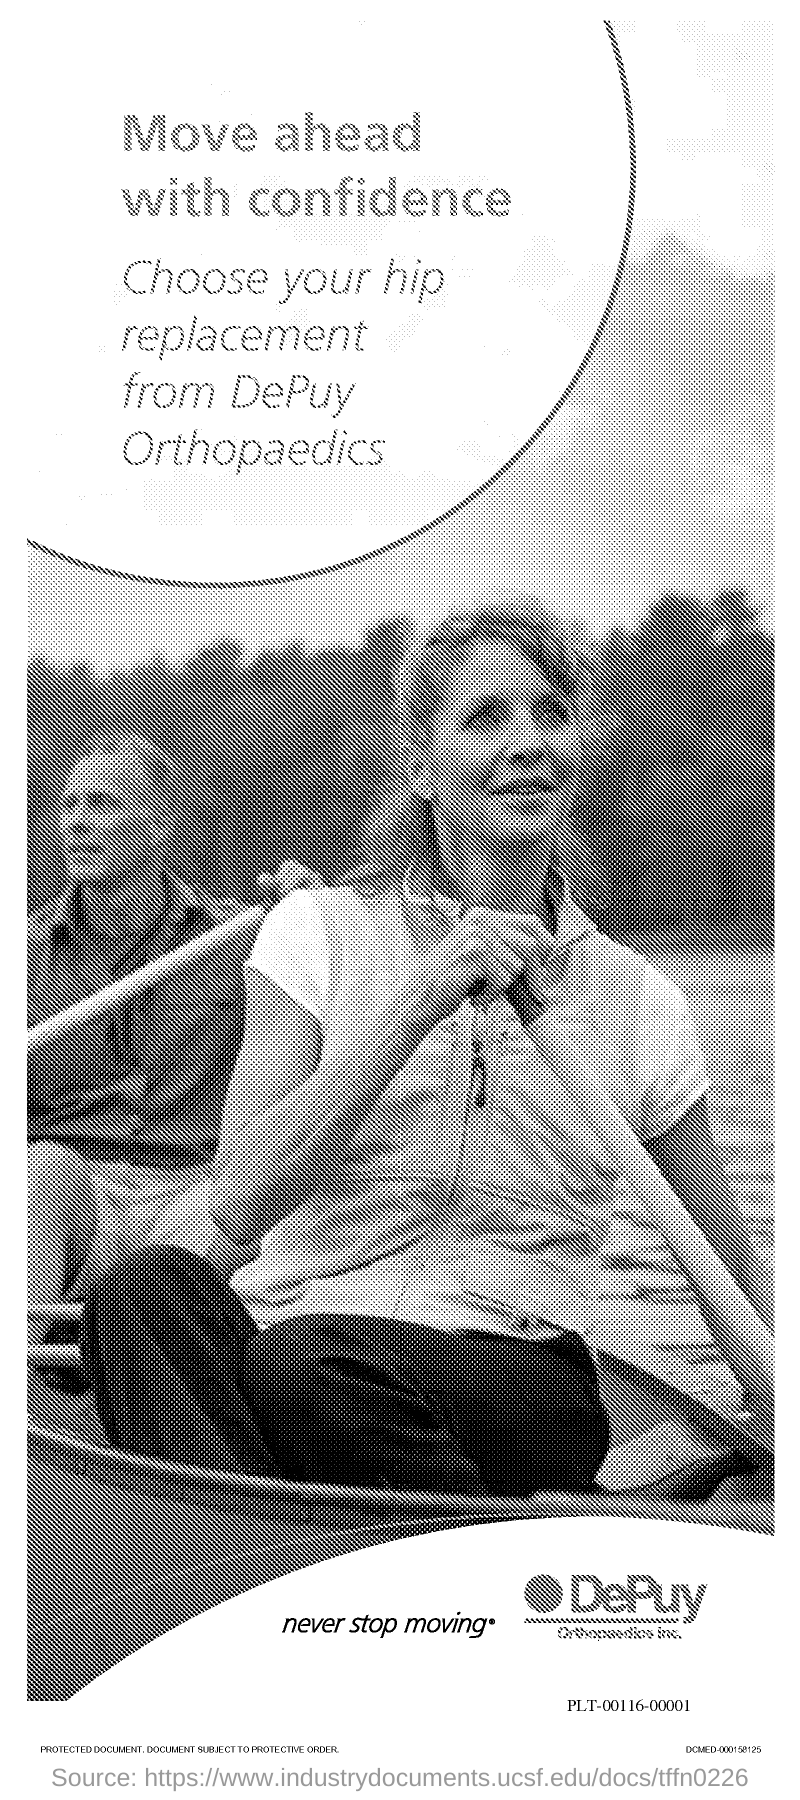Give some essential details in this illustration. The first title in the document is 'Move ahead with confidence' and I am confident in my abilities to proceed with this task. 